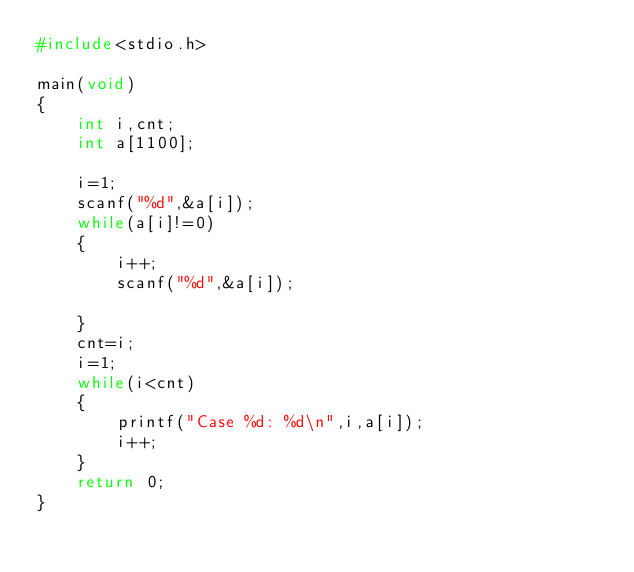Convert code to text. <code><loc_0><loc_0><loc_500><loc_500><_C_>#include<stdio.h>

main(void)
{
	int i,cnt;
	int a[1100];
	
	i=1;
	scanf("%d",&a[i]);
	while(a[i]!=0)
	{
		i++;
		scanf("%d",&a[i]);
		
	}
	cnt=i;
	i=1;
	while(i<cnt)
	{
		printf("Case %d: %d\n",i,a[i]);
		i++;
	}
	return 0;
}</code> 